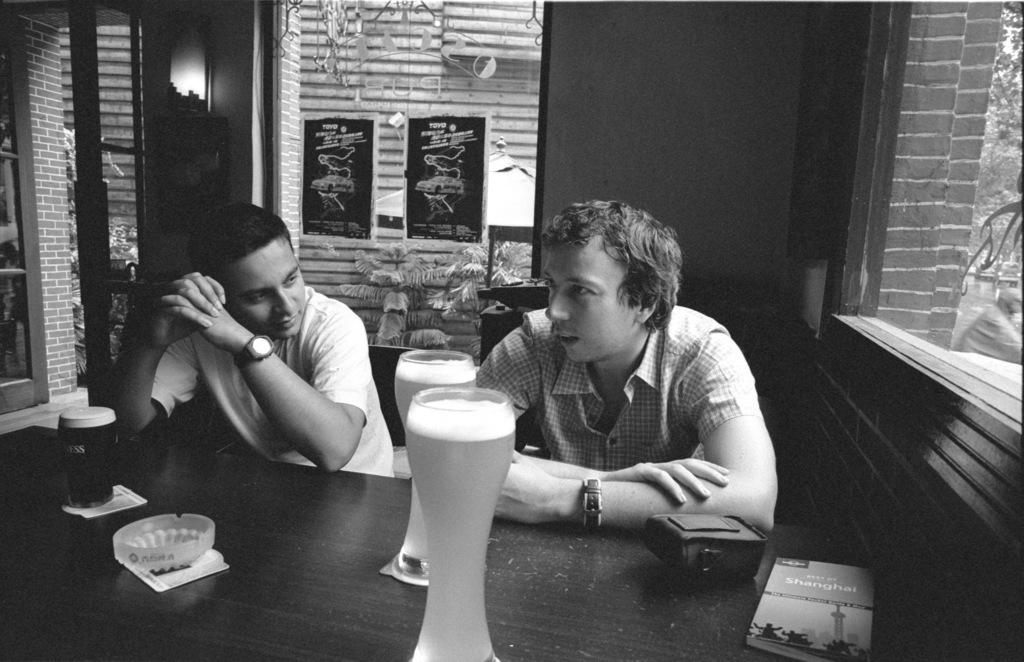What is the person in the image doing? The person is sitting on a chair in the image. What is in front of the person? There is a table in front of the person. What is on the table? There is a glass of wine on the table. Are there any other objects on the table? Yes, there are additional objects present on the table. What type of sponge can be seen on the table in the image? There is no sponge present on the table in the image. What is the person's interest in the objects on the table? The image does not provide information about the person's interest in the objects on the table. --- Facts: 1. There is a car in the image. 2. The car is parked on the street. 3. There are trees in the background. 4. The sky is visible in the image. Absurd Topics: parrot, dance, ocean Conversation: What is the main subject of the image? The main subject of the image is a car. Where is the car located? The car is parked on the street. What can be seen in the background of the image? There are trees in the background. What else is visible in the image? The sky is visible in the image. Reasoning: Let's think step by step in order to produce the conversation. We start by identifying the main subject in the image, which is the car. Then, we describe the car's location, which is parked on the street. Next, we mention the background of the image, which includes trees. Finally, we acknowledge the presence of the sky in the image, which provides context about the weather or time of day. Absurd Question/Answer: Can you tell me how many parrots are sitting on the car in the image? There are no parrots present in the image; it only features a car parked on the street. What type of dance is being performed in the image? There is no dance being performed in the image; it only features a car parked on the street. 